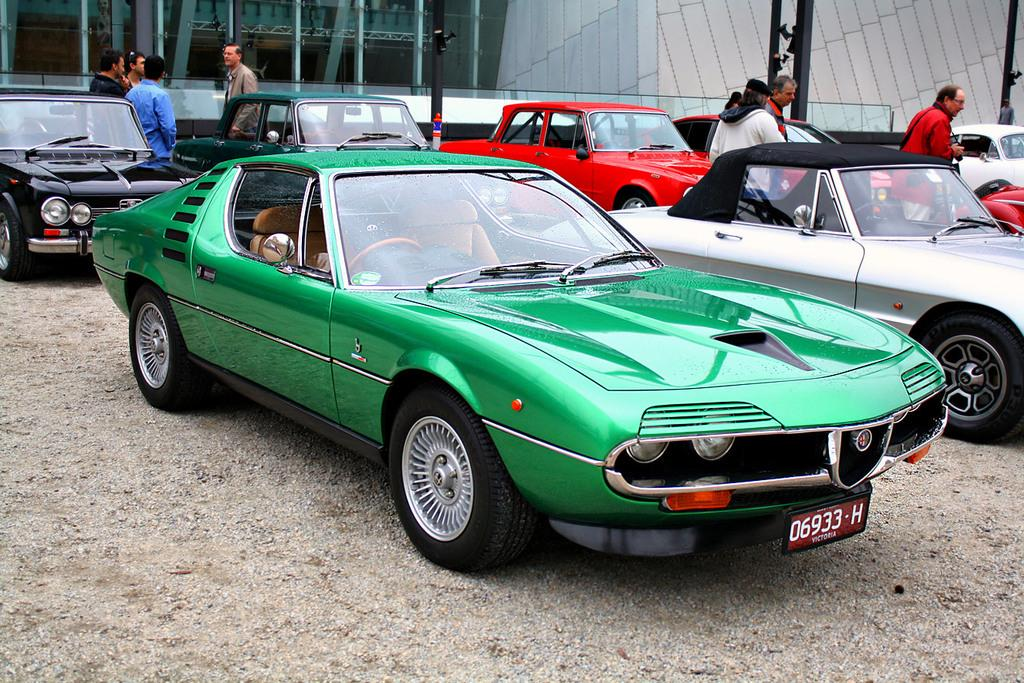What types of objects are present in the image? There are vehicles, people, poles, and a glass wall in the image. Can you describe the vehicles in the image? There is a green car in the image, which has wheels and a number plate. What is the color of the car? The car is green. What is the glass wall in the image used for? The purpose of the glass wall is not specified in the image, but it is likely a barrier or partition. What type of bushes can be seen growing near the green car in the image? There are no bushes visible in the image; it only shows vehicles, people, poles, and a glass wall. What sound can be heard coming from the green car in the image? There is no sound present in the image, as it is a still photograph. 